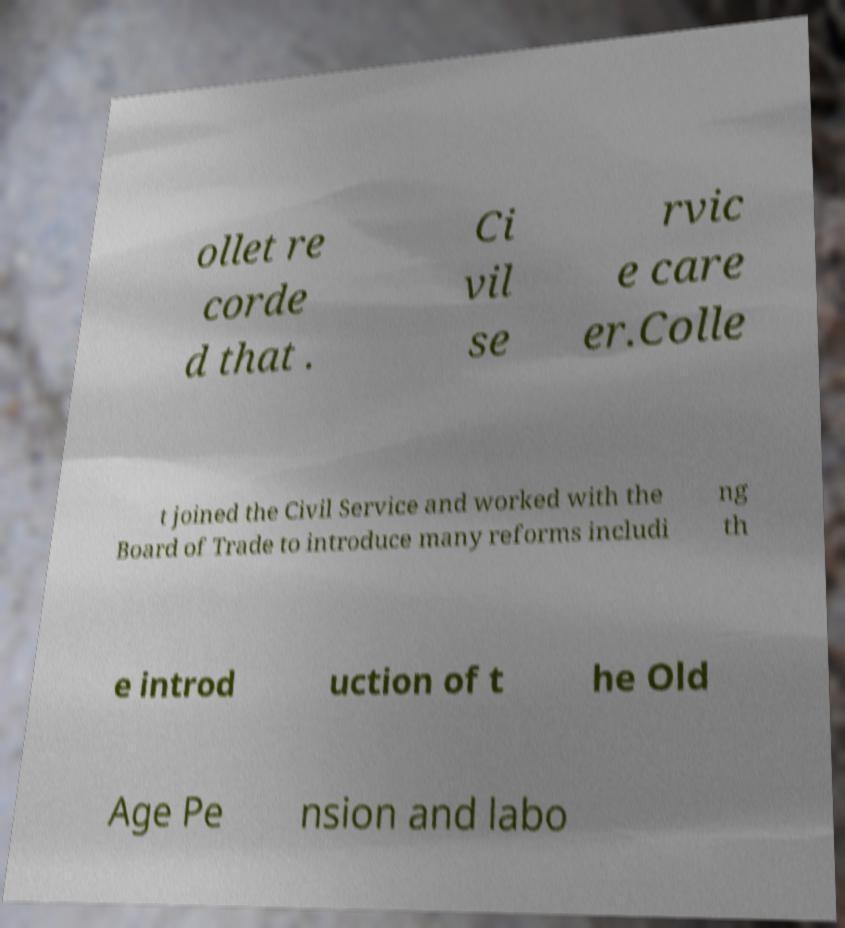What messages or text are displayed in this image? I need them in a readable, typed format. ollet re corde d that . Ci vil se rvic e care er.Colle t joined the Civil Service and worked with the Board of Trade to introduce many reforms includi ng th e introd uction of t he Old Age Pe nsion and labo 